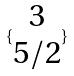<formula> <loc_0><loc_0><loc_500><loc_500>\{ \begin{matrix} 3 \\ 5 / 2 \end{matrix} \}</formula> 